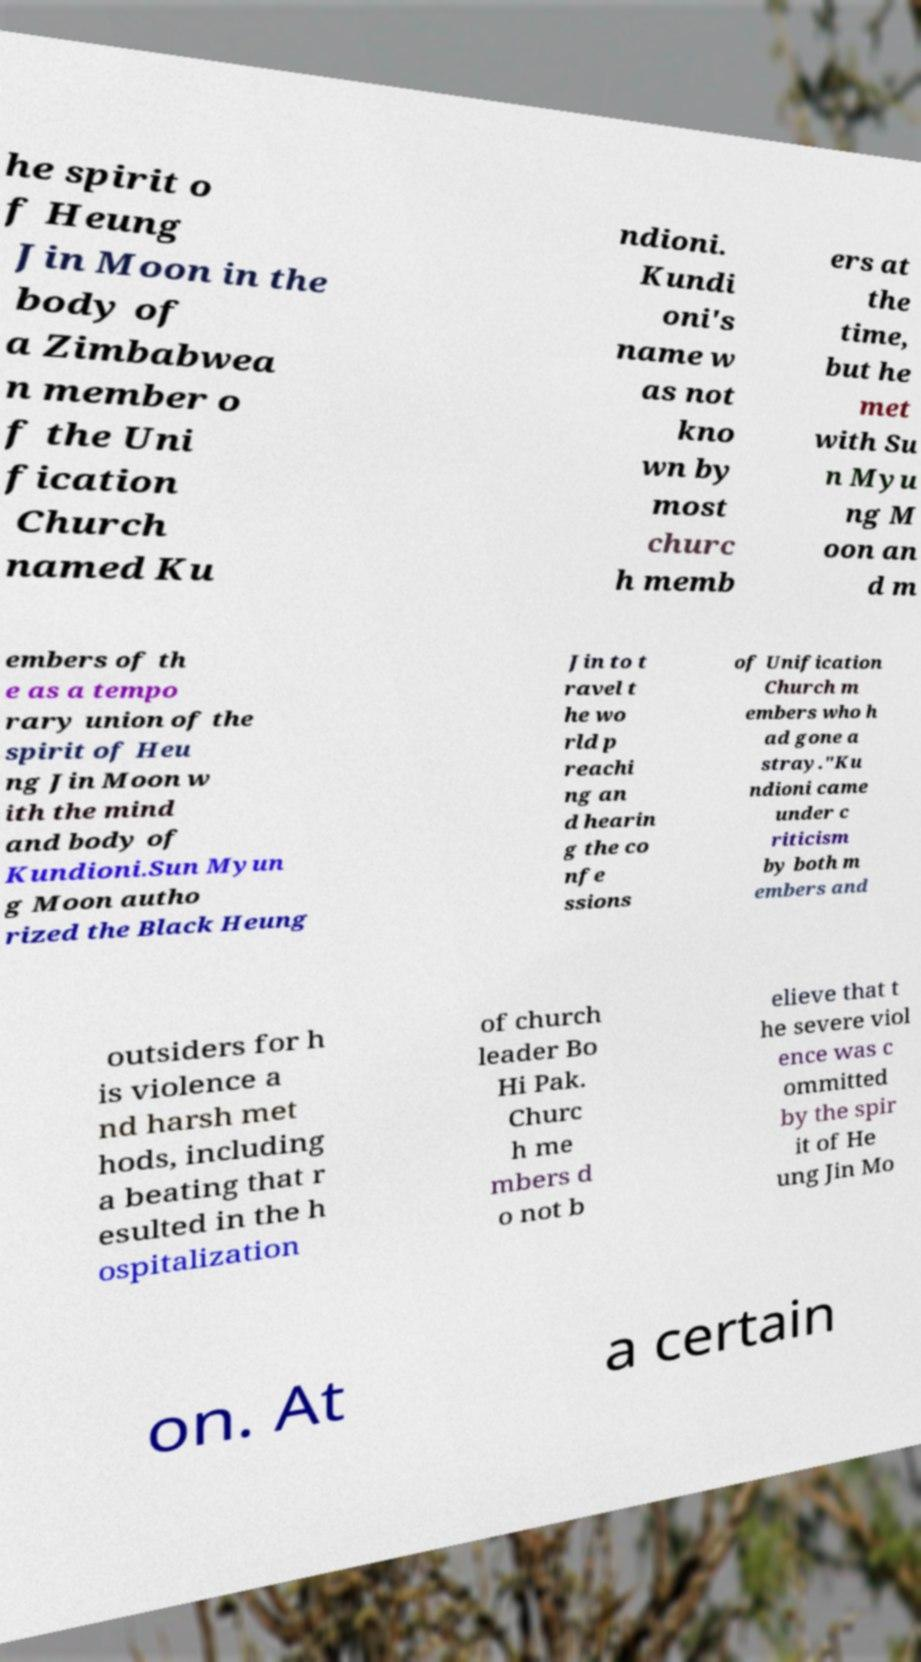Could you assist in decoding the text presented in this image and type it out clearly? he spirit o f Heung Jin Moon in the body of a Zimbabwea n member o f the Uni fication Church named Ku ndioni. Kundi oni's name w as not kno wn by most churc h memb ers at the time, but he met with Su n Myu ng M oon an d m embers of th e as a tempo rary union of the spirit of Heu ng Jin Moon w ith the mind and body of Kundioni.Sun Myun g Moon autho rized the Black Heung Jin to t ravel t he wo rld p reachi ng an d hearin g the co nfe ssions of Unification Church m embers who h ad gone a stray."Ku ndioni came under c riticism by both m embers and outsiders for h is violence a nd harsh met hods, including a beating that r esulted in the h ospitalization of church leader Bo Hi Pak. Churc h me mbers d o not b elieve that t he severe viol ence was c ommitted by the spir it of He ung Jin Mo on. At a certain 